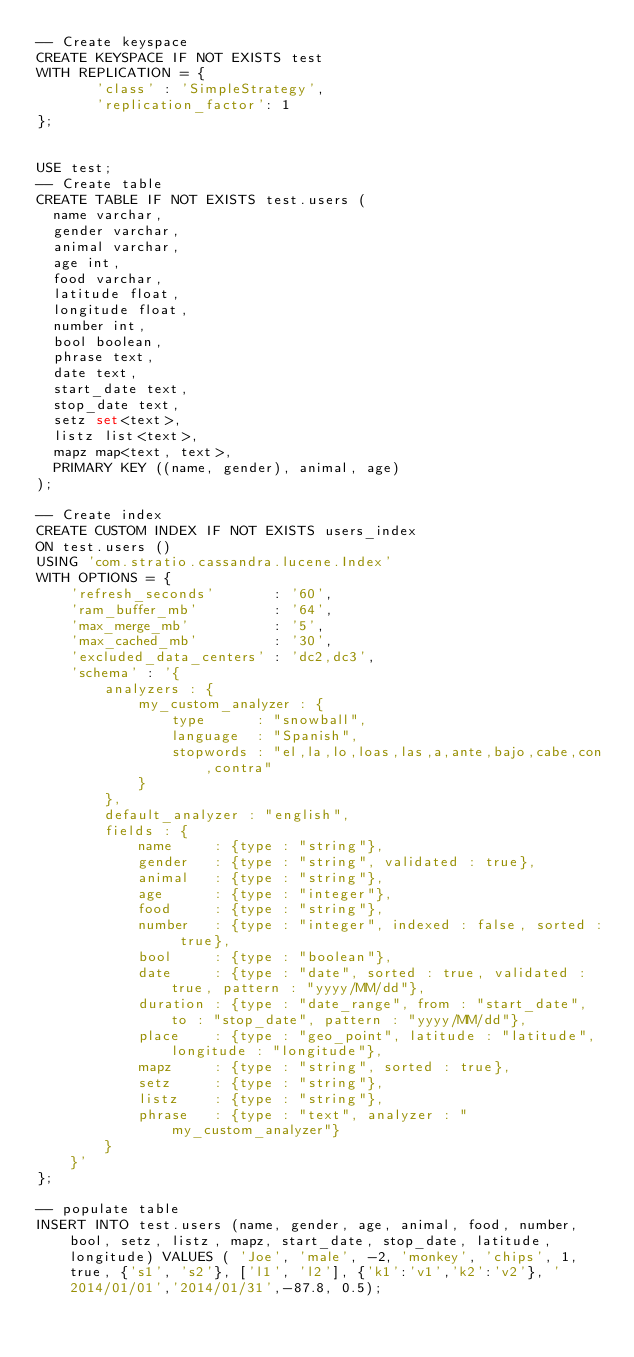<code> <loc_0><loc_0><loc_500><loc_500><_SQL_>-- Create keyspace
CREATE KEYSPACE IF NOT EXISTS test 
WITH REPLICATION = {
       'class' : 'SimpleStrategy', 
       'replication_factor': 1
};


USE test;
-- Create table
CREATE TABLE IF NOT EXISTS test.users (
  name varchar,
  gender varchar,
  animal varchar, 
  age int,
  food varchar, 
  latitude float,
  longitude float,
  number int,
  bool boolean,
  phrase text,
  date text,
  start_date text,
  stop_date text,
  setz set<text>,
  listz list<text>,
  mapz map<text, text>,
  PRIMARY KEY ((name, gender), animal, age)
);

-- Create index
CREATE CUSTOM INDEX IF NOT EXISTS users_index
ON test.users ()
USING 'com.stratio.cassandra.lucene.Index'
WITH OPTIONS = {
    'refresh_seconds'       : '60',
    'ram_buffer_mb'         : '64',
    'max_merge_mb'          : '5',
    'max_cached_mb'         : '30',
    'excluded_data_centers' : 'dc2,dc3',
    'schema' : '{
        analyzers : {
            my_custom_analyzer : {
                type      : "snowball",
                language  : "Spanish",
                stopwords : "el,la,lo,loas,las,a,ante,bajo,cabe,con,contra"
            }
        },
        default_analyzer : "english",
        fields : {
            name     : {type : "string"},
            gender   : {type : "string", validated : true},
            animal   : {type : "string"},
            age      : {type : "integer"},
            food     : {type : "string"},
            number   : {type : "integer", indexed : false, sorted : true},
            bool     : {type : "boolean"},
            date     : {type : "date", sorted : true, validated : true, pattern : "yyyy/MM/dd"},
            duration : {type : "date_range", from : "start_date", to : "stop_date", pattern : "yyyy/MM/dd"},
            place    : {type : "geo_point", latitude : "latitude", longitude : "longitude"},
            mapz     : {type : "string", sorted : true},
            setz     : {type : "string"},
            listz    : {type : "string"},
            phrase   : {type : "text", analyzer : "my_custom_analyzer"}
        }
    }'
};

-- populate table
INSERT INTO test.users (name, gender, age, animal, food, number, bool, setz, listz, mapz, start_date, stop_date, latitude, longitude) VALUES ( 'Joe', 'male', -2, 'monkey', 'chips', 1, true, {'s1', 's2'}, ['l1', 'l2'], {'k1':'v1','k2':'v2'}, '2014/01/01','2014/01/31',-87.8, 0.5);</code> 